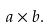Convert formula to latex. <formula><loc_0><loc_0><loc_500><loc_500>a \times b .</formula> 